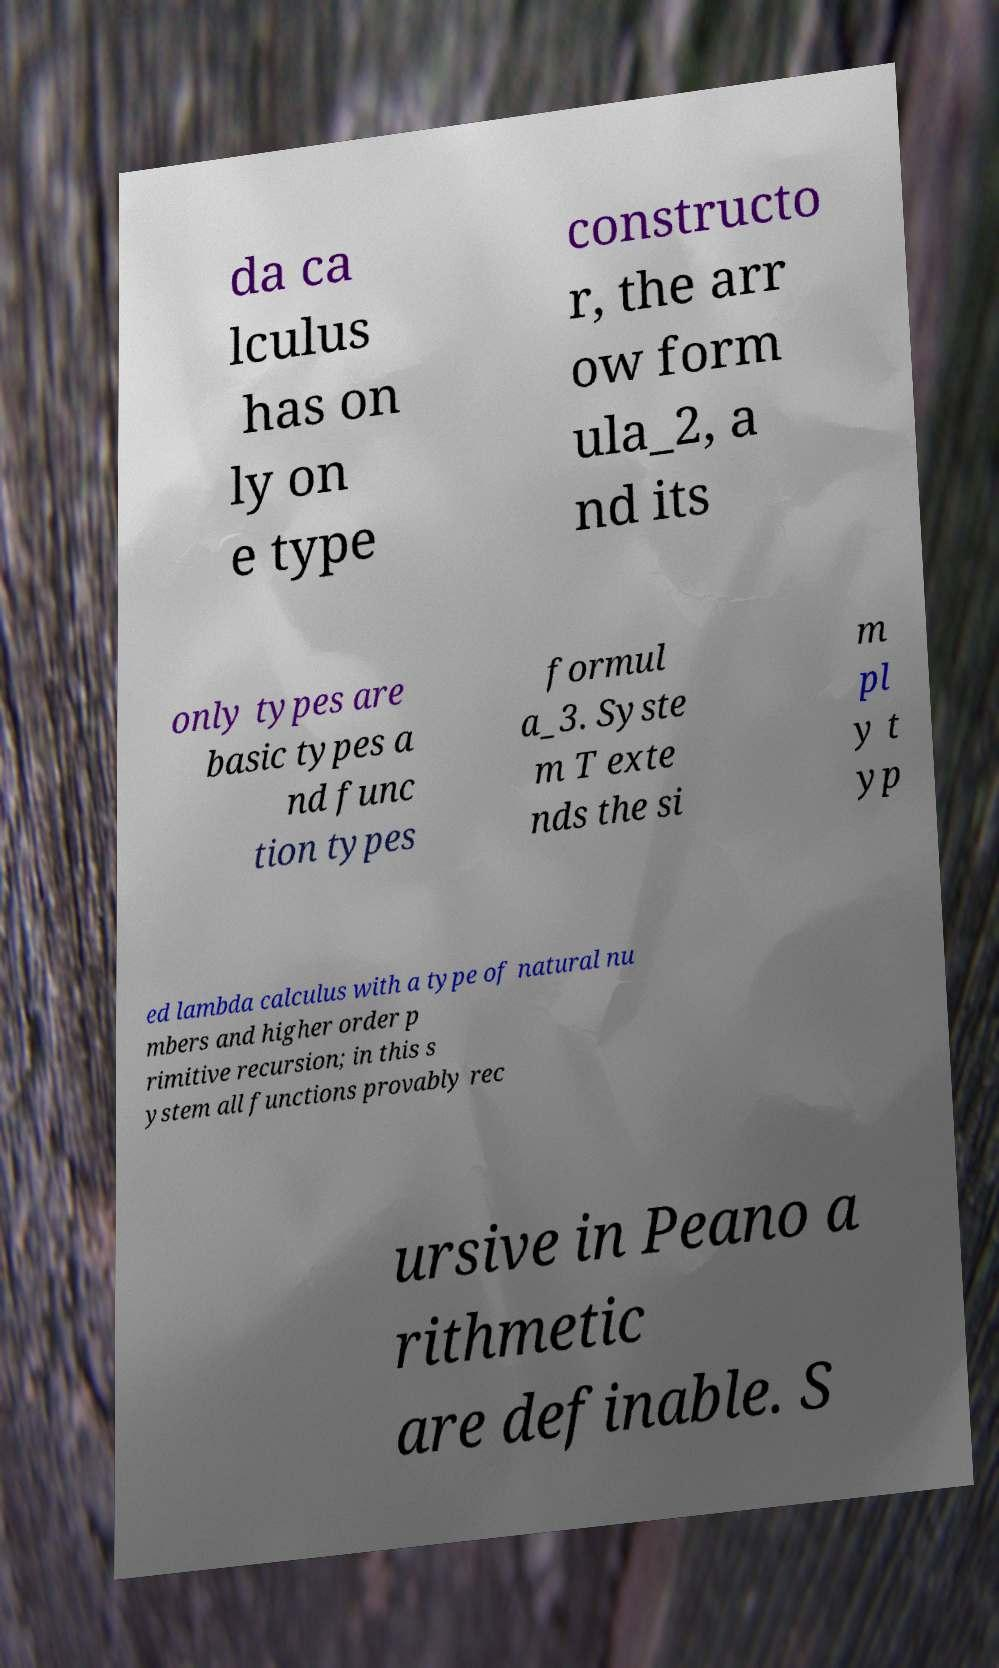Please identify and transcribe the text found in this image. da ca lculus has on ly on e type constructo r, the arr ow form ula_2, a nd its only types are basic types a nd func tion types formul a_3. Syste m T exte nds the si m pl y t yp ed lambda calculus with a type of natural nu mbers and higher order p rimitive recursion; in this s ystem all functions provably rec ursive in Peano a rithmetic are definable. S 